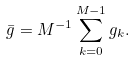Convert formula to latex. <formula><loc_0><loc_0><loc_500><loc_500>\bar { g } = M ^ { - 1 } \sum _ { k = 0 } ^ { M - 1 } g _ { k } .</formula> 